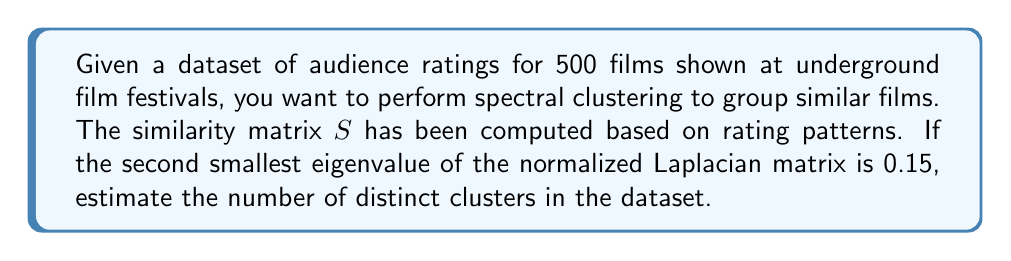Can you solve this math problem? To estimate the number of distinct clusters using spectral clustering, we follow these steps:

1. Recall that the normalized Laplacian matrix $L_{norm}$ is defined as:
   $$L_{norm} = I - D^{-1/2}SD^{-1/2}$$
   where $I$ is the identity matrix, $S$ is the similarity matrix, and $D$ is the degree matrix.

2. The eigenvalues of $L_{norm}$ are in the range [0, 2], with the smallest eigenvalue always being 0.

3. The number of eigenvalues equal to 0 corresponds to the number of connected components in the graph representation of the data.

4. In practice, due to noise in the data, we look for a gap in the eigenvalue spectrum to estimate the number of clusters.

5. The second smallest eigenvalue, often called the algebraic connectivity or Fiedler value, is crucial in this estimation.

6. A rule of thumb is that if the second smallest eigenvalue is close to 0 (typically < 0.1), it suggests multiple distinct clusters.

7. In this case, the second smallest eigenvalue is 0.15, which is relatively small but not extremely close to 0.

8. This suggests that there are likely 2-3 distinct clusters in the dataset.

9. To be more precise, we would need to examine more eigenvalues, but based on the given information, we can estimate 2-3 clusters.
Answer: 2-3 clusters 